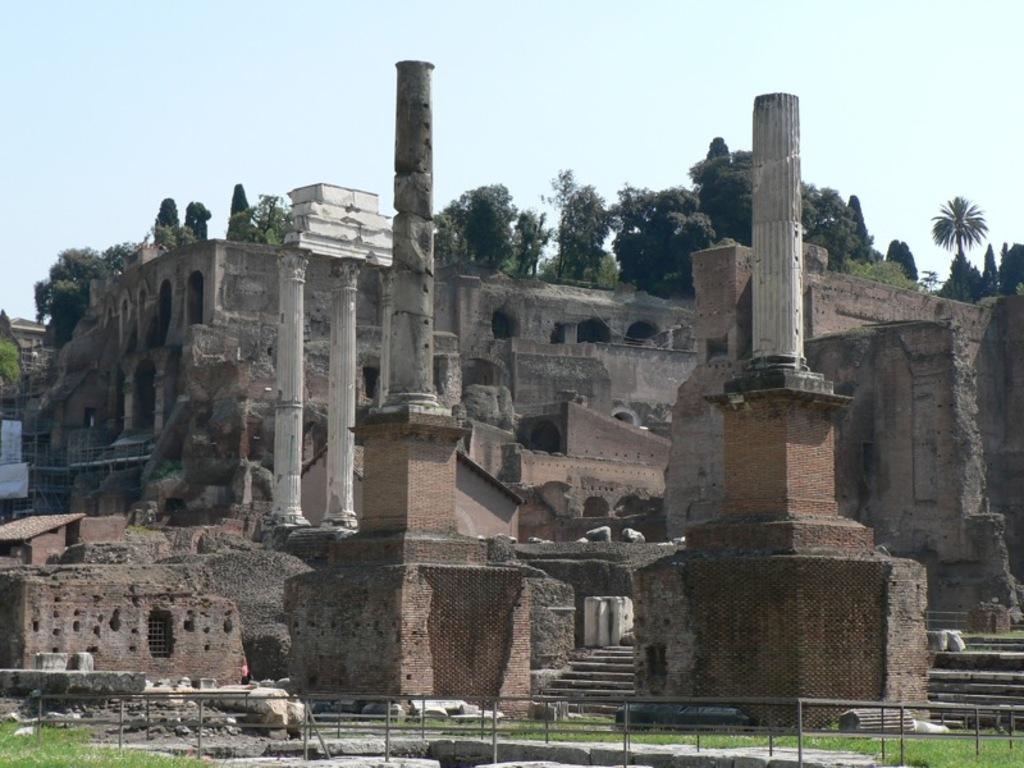How would you summarize this image in a sentence or two? There is a monument as we can see in the middle of this image, and there are some trees on it. There is a sky at the top of this image. 